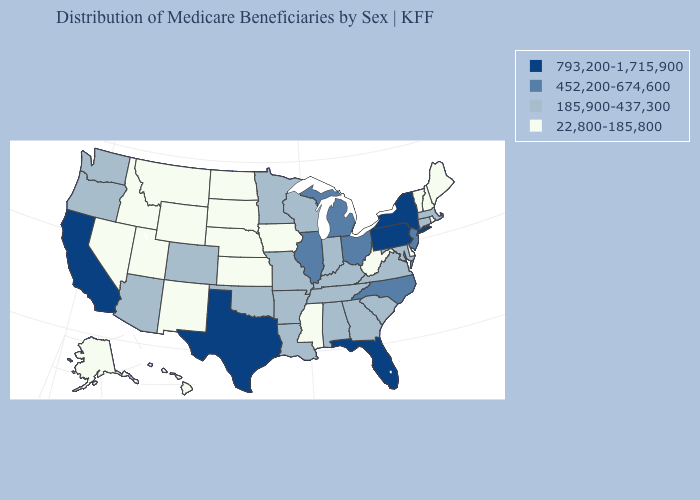Does Maryland have a lower value than Washington?
Write a very short answer. No. Which states have the lowest value in the USA?
Quick response, please. Alaska, Delaware, Hawaii, Idaho, Iowa, Kansas, Maine, Mississippi, Montana, Nebraska, Nevada, New Hampshire, New Mexico, North Dakota, Rhode Island, South Dakota, Utah, Vermont, West Virginia, Wyoming. Among the states that border Utah , which have the lowest value?
Give a very brief answer. Idaho, Nevada, New Mexico, Wyoming. Does West Virginia have a lower value than Massachusetts?
Concise answer only. Yes. What is the value of New Mexico?
Keep it brief. 22,800-185,800. Which states have the lowest value in the Northeast?
Quick response, please. Maine, New Hampshire, Rhode Island, Vermont. Does Hawaii have the lowest value in the West?
Write a very short answer. Yes. Among the states that border Michigan , which have the highest value?
Write a very short answer. Ohio. Does Alaska have a higher value than New Mexico?
Write a very short answer. No. Which states hav the highest value in the MidWest?
Be succinct. Illinois, Michigan, Ohio. What is the value of Kentucky?
Give a very brief answer. 185,900-437,300. Does New Jersey have a higher value than Illinois?
Write a very short answer. No. Does the first symbol in the legend represent the smallest category?
Be succinct. No. Name the states that have a value in the range 793,200-1,715,900?
Keep it brief. California, Florida, New York, Pennsylvania, Texas. How many symbols are there in the legend?
Short answer required. 4. 